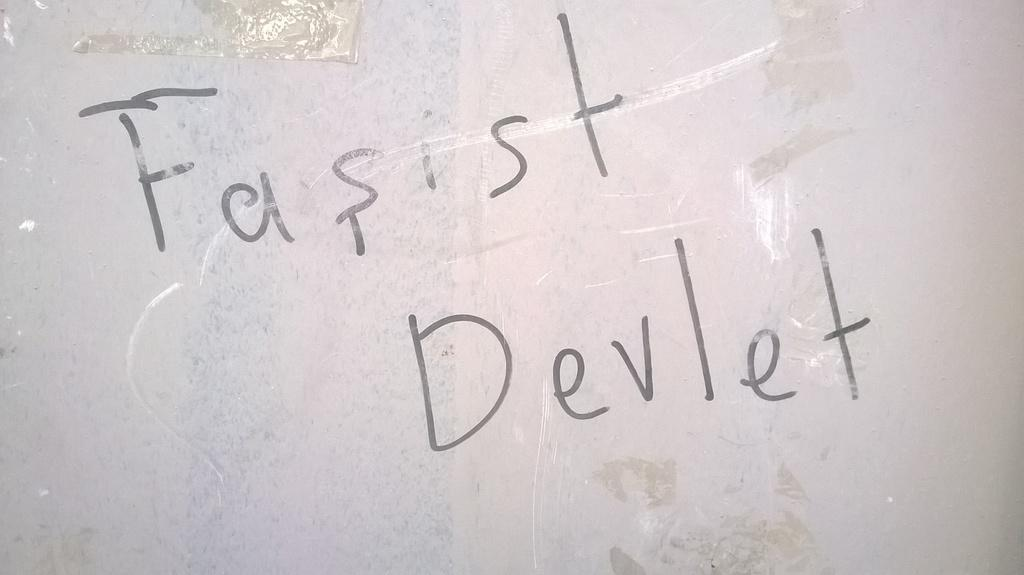<image>
Share a concise interpretation of the image provided. In handwriting the worst Fasist Devlet are in black ink on white paper. 